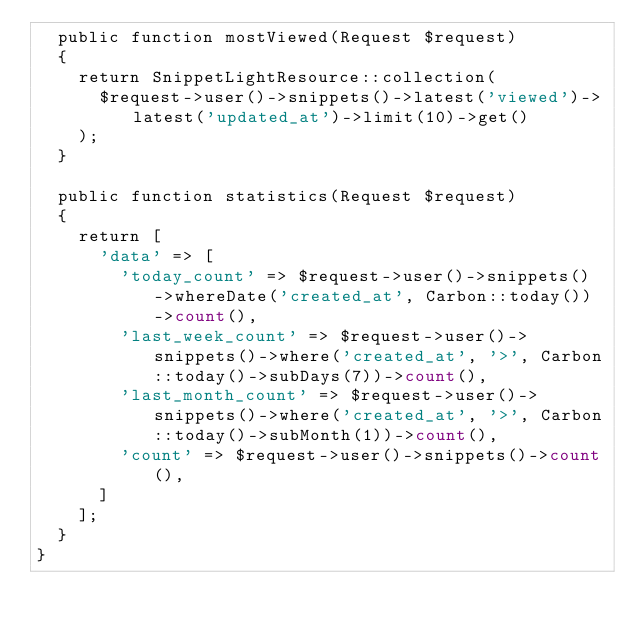<code> <loc_0><loc_0><loc_500><loc_500><_PHP_>  public function mostViewed(Request $request)
  {
    return SnippetLightResource::collection(
      $request->user()->snippets()->latest('viewed')->latest('updated_at')->limit(10)->get()
    );
  }

  public function statistics(Request $request)
  {
    return [
      'data' => [
        'today_count' => $request->user()->snippets()->whereDate('created_at', Carbon::today())->count(),
        'last_week_count' => $request->user()->snippets()->where('created_at', '>', Carbon::today()->subDays(7))->count(),
        'last_month_count' => $request->user()->snippets()->where('created_at', '>', Carbon::today()->subMonth(1))->count(),
        'count' => $request->user()->snippets()->count(),
      ]
    ];
  }
}
</code> 